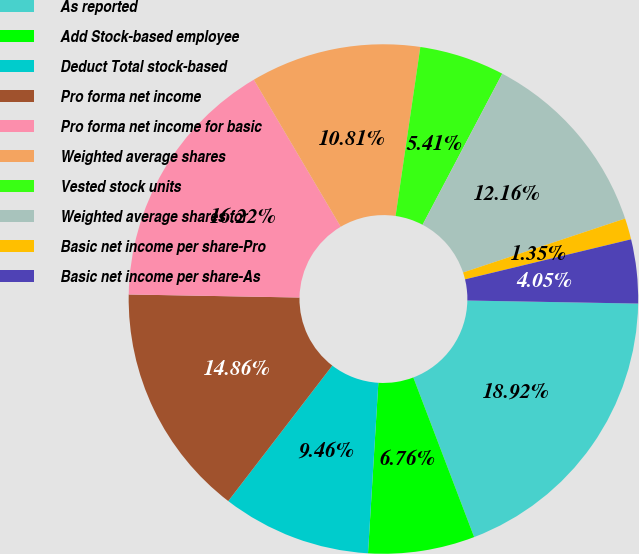Convert chart. <chart><loc_0><loc_0><loc_500><loc_500><pie_chart><fcel>As reported<fcel>Add Stock-based employee<fcel>Deduct Total stock-based<fcel>Pro forma net income<fcel>Pro forma net income for basic<fcel>Weighted average shares<fcel>Vested stock units<fcel>Weighted average shares for<fcel>Basic net income per share-Pro<fcel>Basic net income per share-As<nl><fcel>18.92%<fcel>6.76%<fcel>9.46%<fcel>14.86%<fcel>16.22%<fcel>10.81%<fcel>5.41%<fcel>12.16%<fcel>1.35%<fcel>4.05%<nl></chart> 